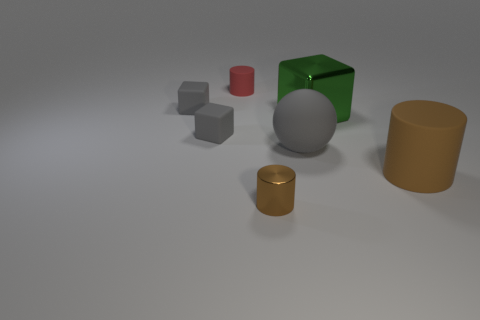What number of objects are gray objects that are left of the red matte cylinder or shiny things to the right of the big gray rubber sphere?
Offer a very short reply. 3. What is the material of the brown cylinder that is the same size as the red object?
Provide a short and direct response. Metal. How many other objects are the same material as the red thing?
Make the answer very short. 4. Is the number of red rubber objects right of the large brown rubber thing the same as the number of shiny cylinders on the right side of the green cube?
Keep it short and to the point. Yes. What number of yellow objects are either balls or big rubber objects?
Your answer should be very brief. 0. There is a matte sphere; is its color the same as the matte cube that is behind the large green object?
Give a very brief answer. Yes. What number of other things are there of the same color as the large rubber cylinder?
Make the answer very short. 1. Are there fewer green things than matte blocks?
Keep it short and to the point. Yes. How many green things are to the left of the tiny thing in front of the brown thing right of the rubber sphere?
Provide a succinct answer. 0. What size is the rubber object in front of the rubber sphere?
Offer a very short reply. Large. 